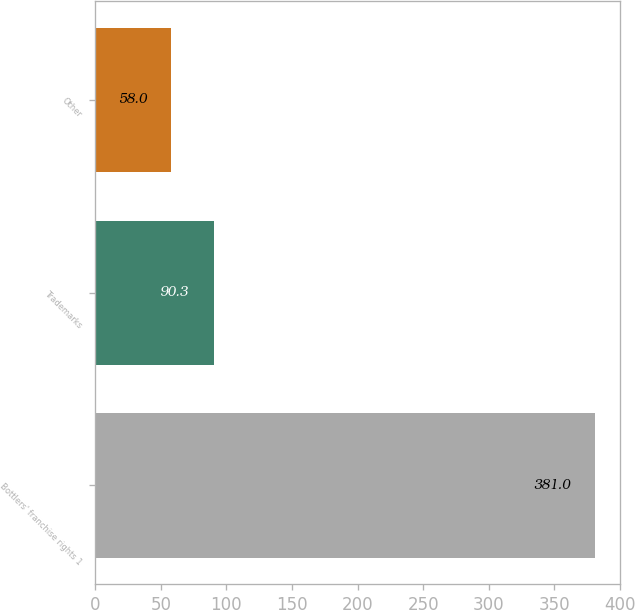Convert chart to OTSL. <chart><loc_0><loc_0><loc_500><loc_500><bar_chart><fcel>Bottlers' franchise rights 1<fcel>Trademarks<fcel>Other<nl><fcel>381<fcel>90.3<fcel>58<nl></chart> 